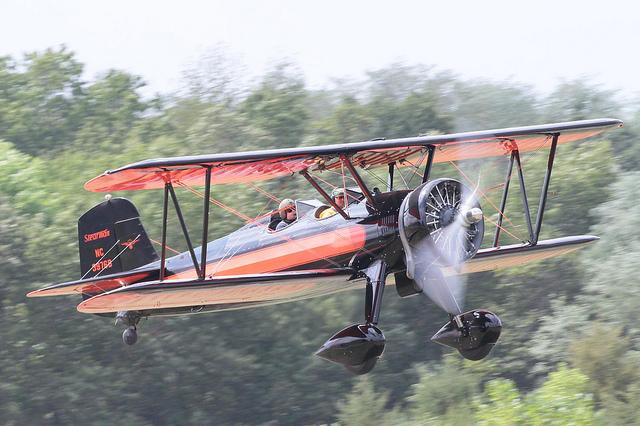What color is the plane?
Quick response, please. Red and black. How many people are in the plane?
Write a very short answer. 2. What can be seen behind the plane?
Keep it brief. Trees. 